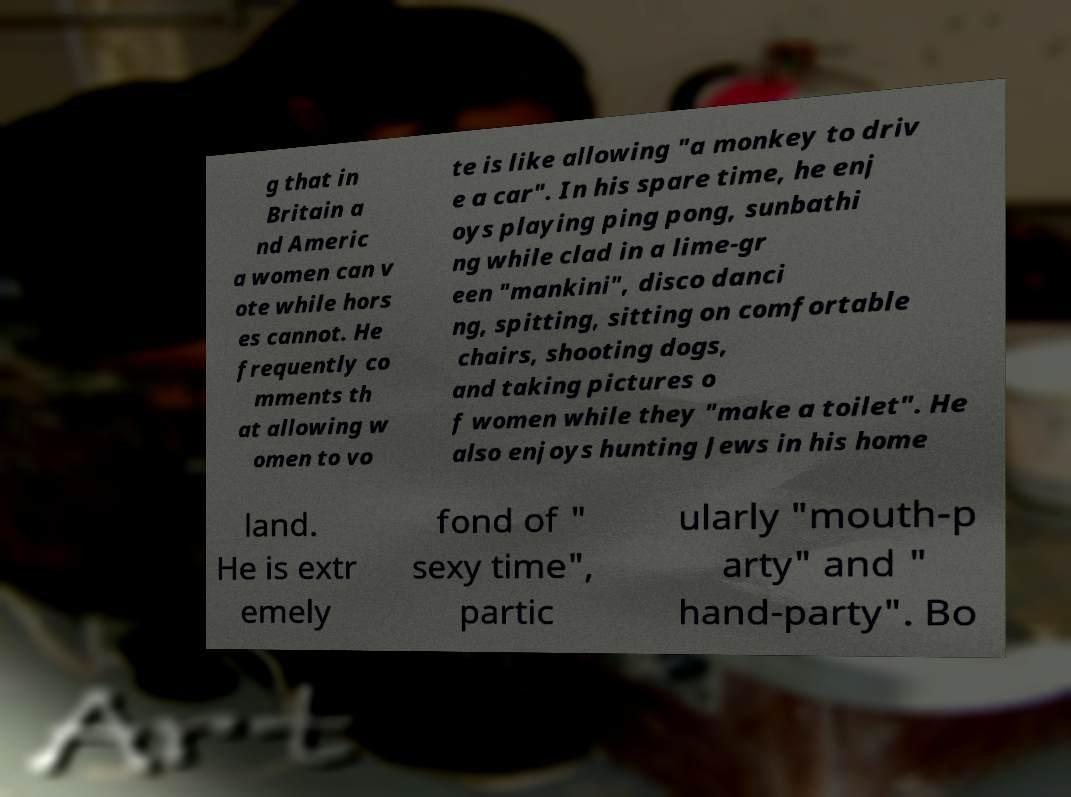Can you accurately transcribe the text from the provided image for me? g that in Britain a nd Americ a women can v ote while hors es cannot. He frequently co mments th at allowing w omen to vo te is like allowing "a monkey to driv e a car". In his spare time, he enj oys playing ping pong, sunbathi ng while clad in a lime-gr een "mankini", disco danci ng, spitting, sitting on comfortable chairs, shooting dogs, and taking pictures o f women while they "make a toilet". He also enjoys hunting Jews in his home land. He is extr emely fond of " sexy time", partic ularly "mouth-p arty" and " hand-party". Bo 